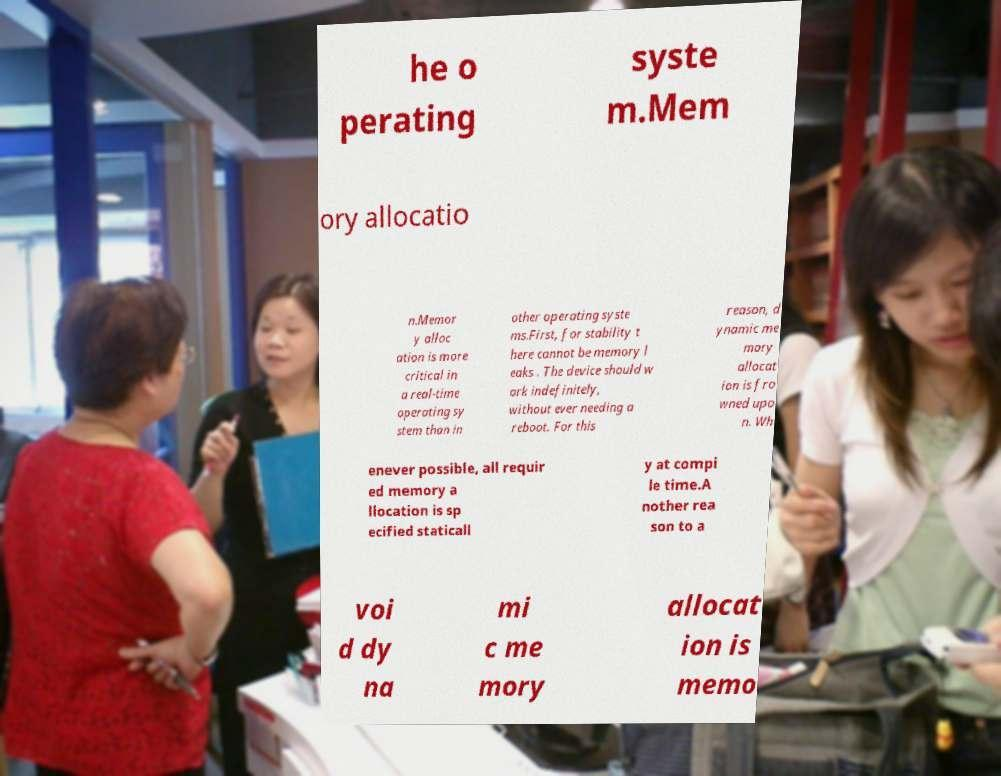Could you extract and type out the text from this image? he o perating syste m.Mem ory allocatio n.Memor y alloc ation is more critical in a real-time operating sy stem than in other operating syste ms.First, for stability t here cannot be memory l eaks . The device should w ork indefinitely, without ever needing a reboot. For this reason, d ynamic me mory allocat ion is fro wned upo n. Wh enever possible, all requir ed memory a llocation is sp ecified staticall y at compi le time.A nother rea son to a voi d dy na mi c me mory allocat ion is memo 